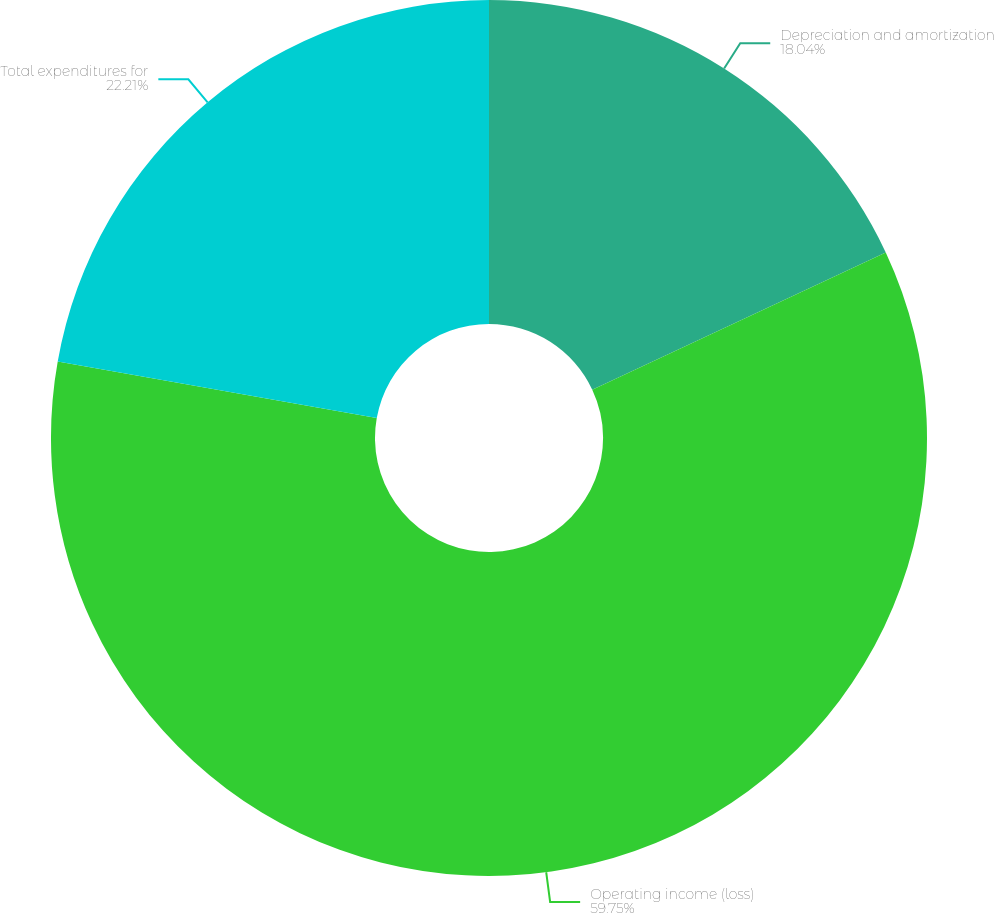<chart> <loc_0><loc_0><loc_500><loc_500><pie_chart><fcel>Depreciation and amortization<fcel>Operating income (loss)<fcel>Total expenditures for<nl><fcel>18.04%<fcel>59.76%<fcel>22.21%<nl></chart> 